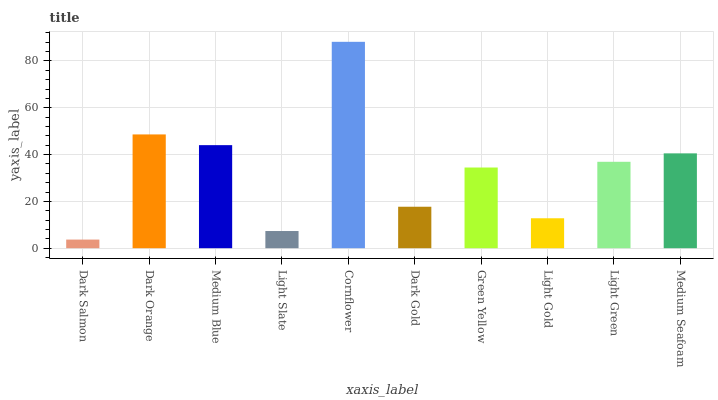Is Dark Salmon the minimum?
Answer yes or no. Yes. Is Cornflower the maximum?
Answer yes or no. Yes. Is Dark Orange the minimum?
Answer yes or no. No. Is Dark Orange the maximum?
Answer yes or no. No. Is Dark Orange greater than Dark Salmon?
Answer yes or no. Yes. Is Dark Salmon less than Dark Orange?
Answer yes or no. Yes. Is Dark Salmon greater than Dark Orange?
Answer yes or no. No. Is Dark Orange less than Dark Salmon?
Answer yes or no. No. Is Light Green the high median?
Answer yes or no. Yes. Is Green Yellow the low median?
Answer yes or no. Yes. Is Light Gold the high median?
Answer yes or no. No. Is Light Green the low median?
Answer yes or no. No. 